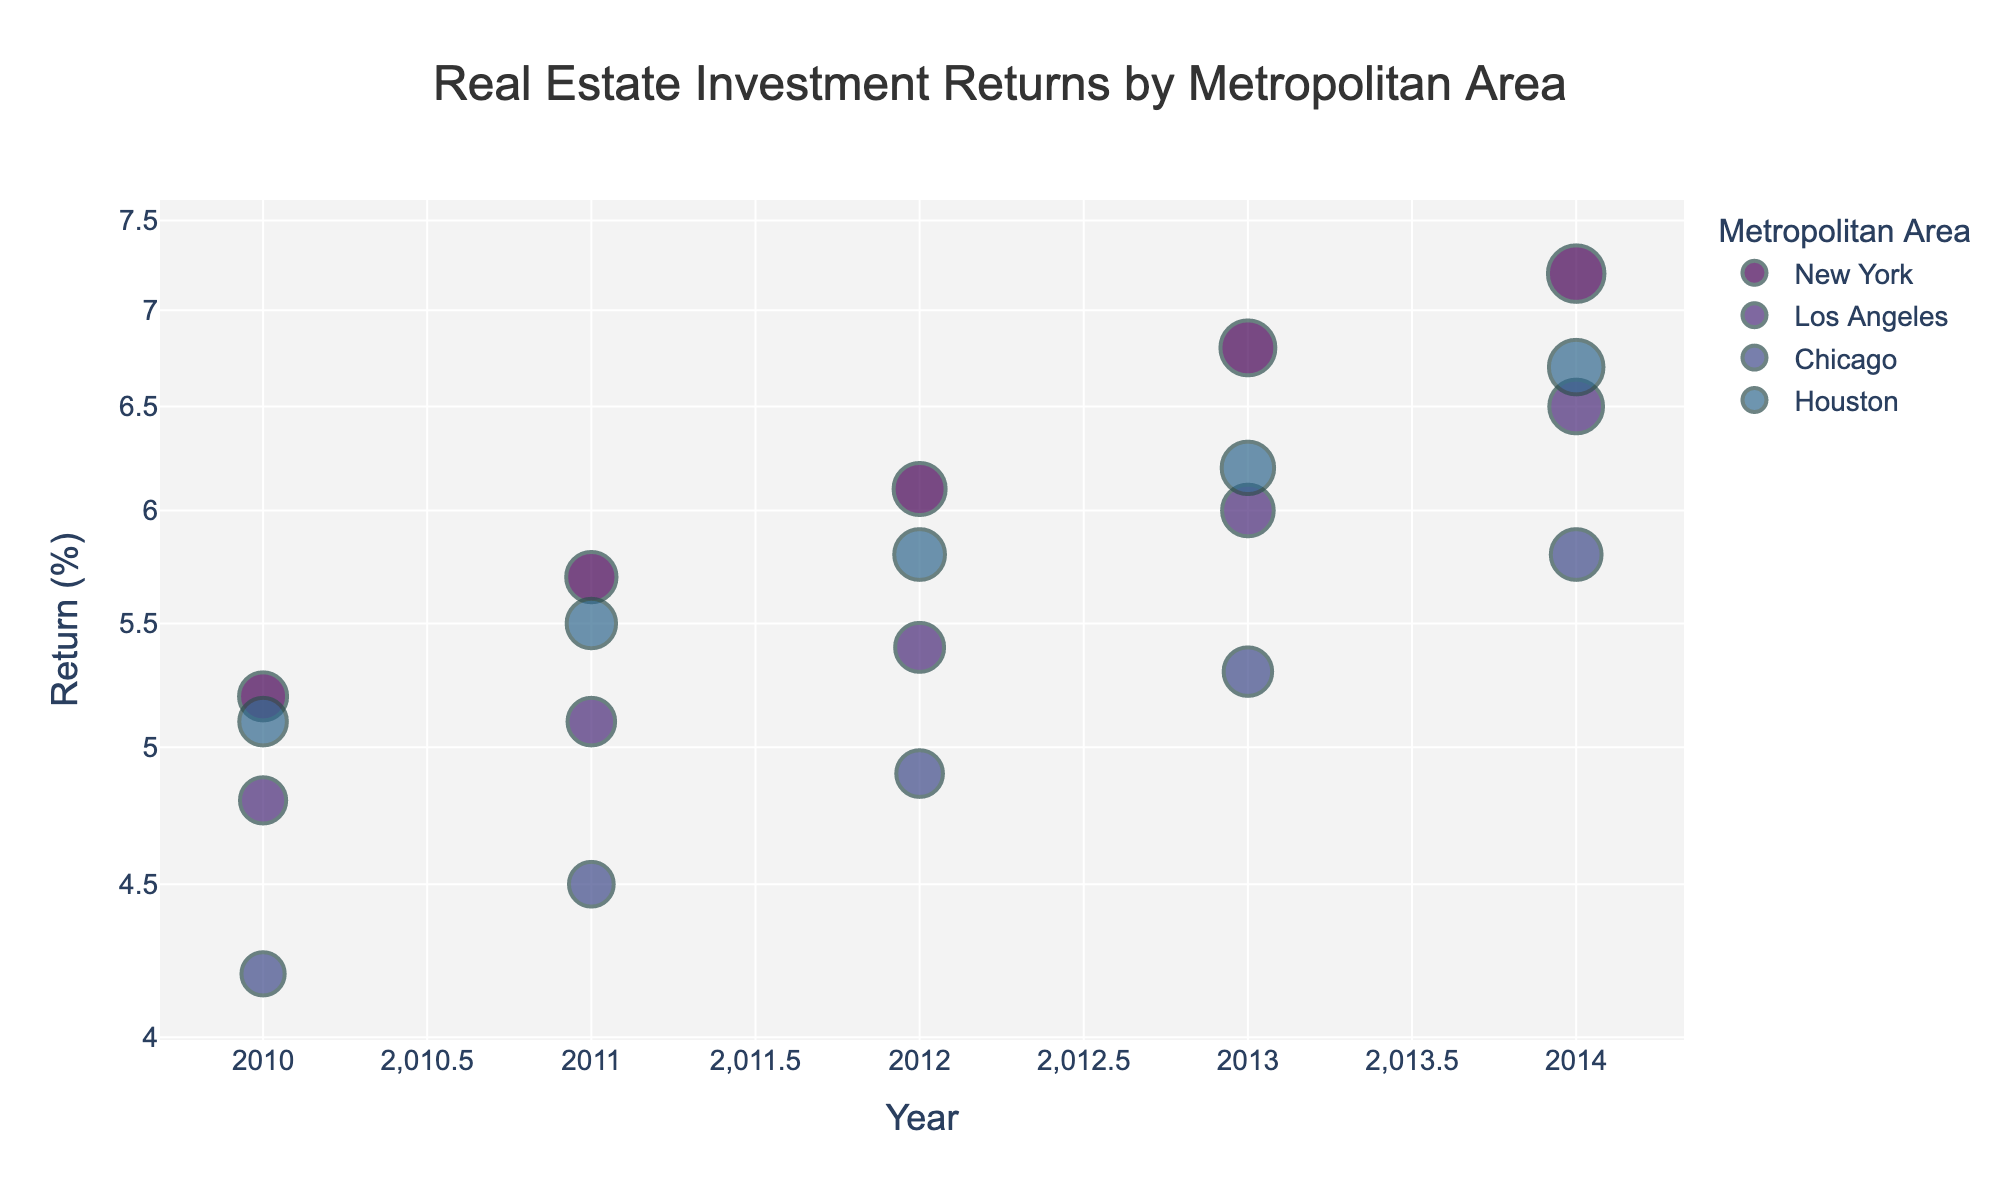What is the title of the scatter plot? The title is usually displayed at the top of the figure. In this scatter plot, it's centrally aligned.
Answer: Real Estate Investment Returns by Metropolitan Area Which Metropolitan Area had the highest investment return in 2012? Locate the data points for 2012 on the x-axis. Compare the y-values.
Answer: New York How did the real estate investment return in Los Angeles change from 2011 to 2014? Look at the data points for Los Angeles from 2011 to 2014. Observe the trend in y-values.
Answer: Increased from 5.1% to 6.5% Between Chicago and Houston, which metropolitan area had a higher investment return in 2013? Find data points for Chicago and Houston in 2013. Compare their y-values.
Answer: Houston What is the average real estate investment return in New York over the given years? Sum the returns for New York from 2010 to 2014. Divide by the number of years.
Answer: (5.2 + 5.7 + 6.1 + 6.8 + 7.2) / 5 = 6.2% Which year had the lowest real estate investment return in Chicago? Identify the data points for Chicago and compare their y-values.
Answer: 2010 How does the investment return in Chicago in 2011 compare to that in 2013? Compare the y-values for Chicago in 2011 and 2013.
Answer: Lower in 2011 (4.5% vs. 5.3%) What is the pattern of investment returns for Houston from 2010 to 2014? Observe the trend of y-values for Houston from 2010 to 2014.
Answer: Increasing trend In which year did New York see the largest annual increase in investment returns? Calculate the differences in returns for consecutive years in New York.
Answer: 2013 (6.8% - 6.1% = 0.7%) Are there any metropolitan areas with overlapping investment returns in any given year? Look for data points with similar y-values in the same year across different metropolitan areas.
Answer: No 